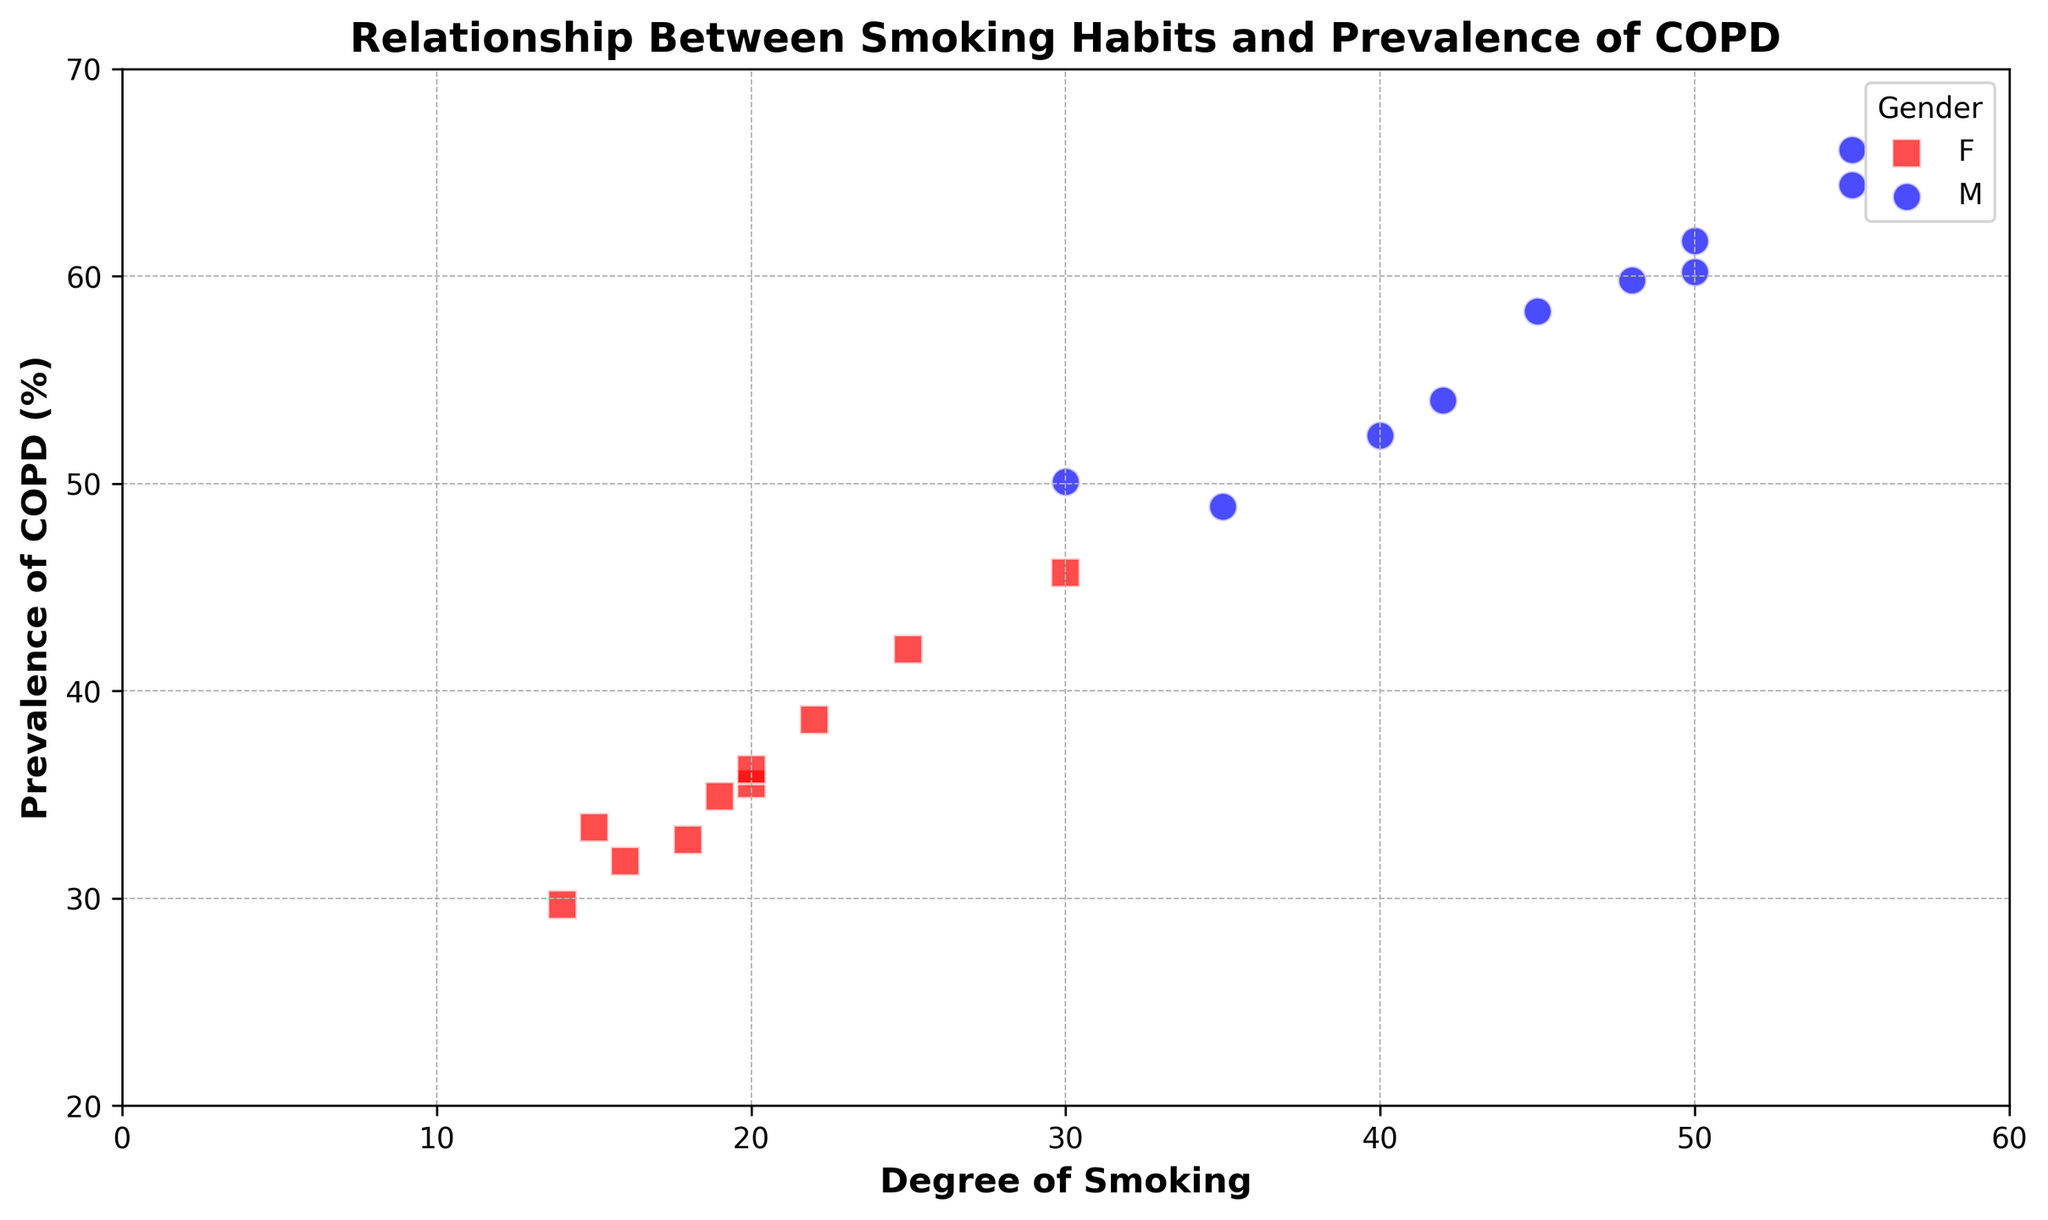What's the gender with the highest Degree of Smoking? Look at the scatter plot for points that depict the highest Degree of Smoking. Both genders are compared, and the highest Degree of Smoking occurs at 55 for Males (M).
Answer: Male What is the average Prevalence of COPD for Females (F)? Identify all points for Females (red squares). Sum their Prevalence of COPD values (35.5, 45.7, 33.4, 42.0, 36.2, 32.8, 38.6, 34.9, 31.8, 29.7), which equals 360.6, then divide by the number of Female points (10).
Answer: 36.06 Which gender generally shows a higher Prevalence of COPD for a given Degree of Smoking of 50? Compare the points for both genders at Degree of Smoking of 50. Males (blue circles) show Prevalence of COPD values of 60.2, 61.7 and 59.8 which on average is higher than Females (red squares).
Answer: Males How does the Prevalence of COPD trend for Males vary with Degree of Smoking? Look at the blue circles representing Males. As the Degree of Smoking increases, the Prevalence of COPD also increases, showing a direct relationship.
Answer: It increases Which age group has the lowest Prevalence of COPD among Females? Identify the points for Females and note the ages. The lowest Prevalence of COPD for Females is 29.7, which occurs at age 52.
Answer: 52 Is there any overlap in Prevalence of COPD between Males and Females for a Degree of Smoking of 20? Find points where Degree of Smoking is 20 for both genders. Females have Prevalence of 35.5 and 36.2, Males have none. Hence, no overlapping Prevalence values.
Answer: No Compare the variation in Prevalence of COPD between the genders visually. Who shows more variation? Look at the spread of points color-wise. Males (blue circles) points show a wider range in Prevalence of COPD compared to Females (red squares).
Answer: Males What can you say about the relationship between Age and Prevalence of COPD in this scatter plot? Observe the trend in ages (x-axis) and the prevalence points (y-axis). No direct relationship is visible between Age and Prevalence of COPD since trends align more with Degree of Smoking.
Answer: No direct relationship 